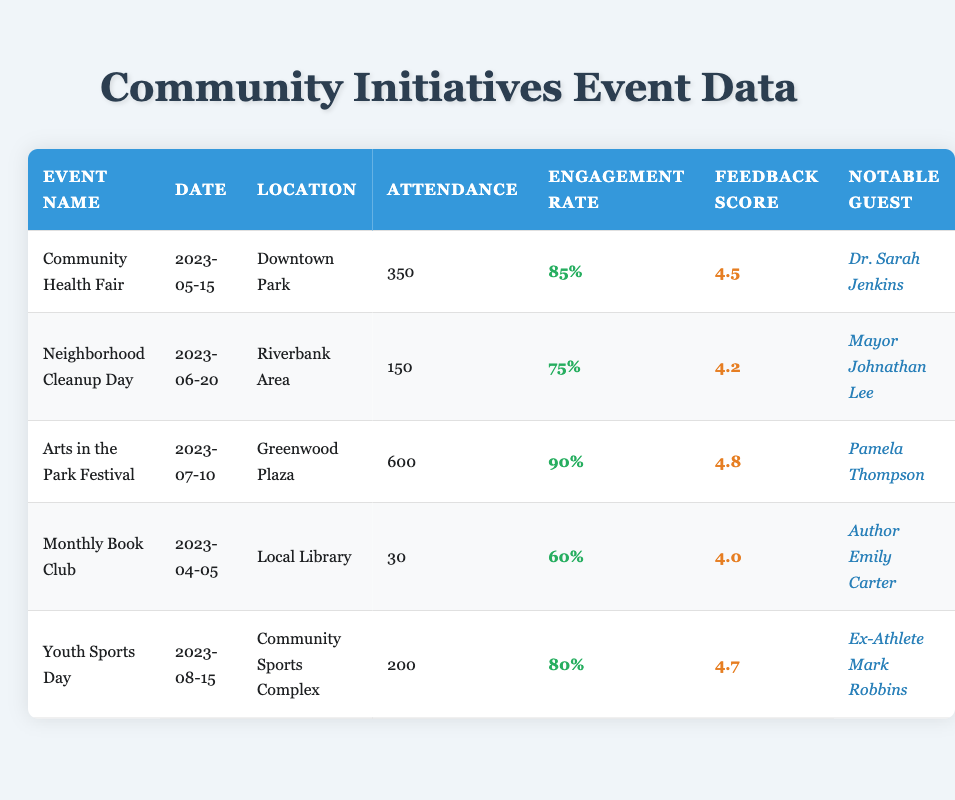What was the total attendance for the Community Health Fair and Youth Sports Day? The attendance for the Community Health Fair is 350, and for Youth Sports Day, it is 200. Summing these values gives us 350 + 200 = 550.
Answer: 550 Which event had the highest engagement rate and what was that rate? The event with the highest engagement rate is the Arts in the Park Festival with an engagement rate of 90%.
Answer: 90% Is the feedback score for the Monthly Book Club higher than that of the Neighborhood Cleanup Day? Monthly Book Club has a feedback score of 4.0, while Neighborhood Cleanup Day has a score of 4.2. Since 4.0 is less than 4.2, the statement is false.
Answer: No What is the average attendance across all events? We have 5 events with attendance values: 350, 150, 600, 30, and 200. The total attendance is 350 + 150 + 600 + 30 + 200 = 1330. The average attendance is 1330 / 5 = 266.
Answer: 266 Did Dr. Sarah Jenkins attend any events other than the Community Health Fair? According to the data, Dr. Sarah Jenkins is only listed as the notable guest for the Community Health Fair, meaning she did not attend any other event.
Answer: No What were the notable guests for events with an engagement rate above 80%? The events with an engagement rate above 80% are the Arts in the Park Festival (notable guest: Pamela Thompson) and the Community Health Fair (notable guest: Dr. Sarah Jenkins).
Answer: Pamela Thompson, Dr. Sarah Jenkins What is the difference in feedback scores between the Arts in the Park Festival and the Monthly Book Club? The feedback score for the Arts in the Park Festival is 4.8, and for the Monthly Book Club, it is 4.0. The difference is calculated as 4.8 - 4.0 = 0.8.
Answer: 0.8 Which event occurred first in the timeline? By looking at the dates, the Monthly Book Club held on April 5, 2023, is the earliest event when compared to others.
Answer: Monthly Book Club How many events had an attendance of less than 100? Reviewing the attendance numbers for all events, only the Monthly Book Club had an attendance of 30, which is less than 100. Therefore, there is 1 event in this category.
Answer: 1 